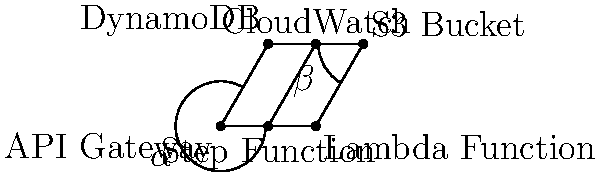In the serverless architecture deployment flowchart above, which two angles are congruent? To determine which angles are congruent in this serverless architecture deployment flowchart, we need to analyze the geometric properties of the diagram:

1. The diagram forms a parallelogram ABDC with a diagonal EF.

2. In a parallelogram, opposite angles are congruent.

3. The angle marked $\alpha$ is formed by the API Gateway (A), Step Function (E), and DynamoDB (C) components.

4. The angle marked $\beta$ is formed by the S3 Bucket (D), Lambda Function (B), and CloudWatch (F) components.

5. Observe that $\alpha$ and $\beta$ are located at opposite corners of the parallelogram.

6. Since opposite angles in a parallelogram are congruent, we can conclude that $\alpha$ and $\beta$ are congruent angles.

This congruence reflects the symmetry often found in well-designed serverless architectures, where components at different stages of the workflow may have similar relationships and interactions.
Answer: $\alpha$ and $\beta$ 